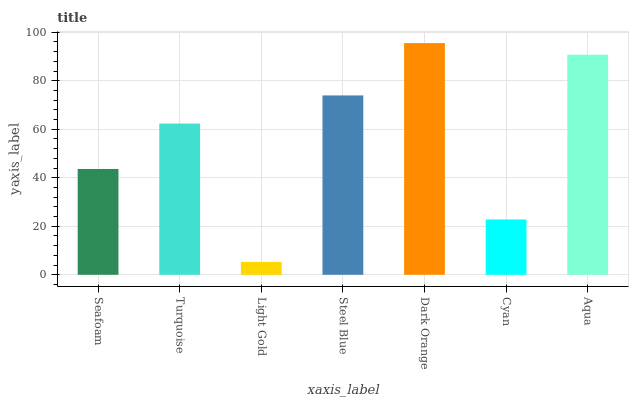Is Turquoise the minimum?
Answer yes or no. No. Is Turquoise the maximum?
Answer yes or no. No. Is Turquoise greater than Seafoam?
Answer yes or no. Yes. Is Seafoam less than Turquoise?
Answer yes or no. Yes. Is Seafoam greater than Turquoise?
Answer yes or no. No. Is Turquoise less than Seafoam?
Answer yes or no. No. Is Turquoise the high median?
Answer yes or no. Yes. Is Turquoise the low median?
Answer yes or no. Yes. Is Dark Orange the high median?
Answer yes or no. No. Is Steel Blue the low median?
Answer yes or no. No. 